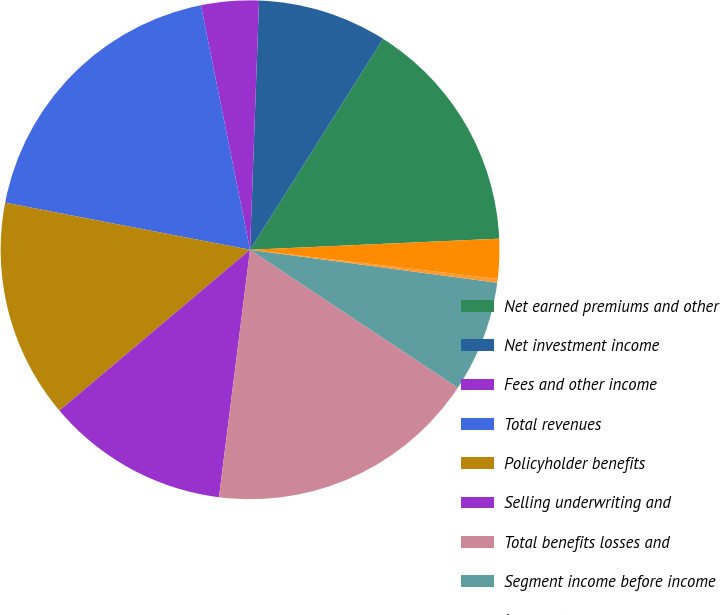<chart> <loc_0><loc_0><loc_500><loc_500><pie_chart><fcel>Net earned premiums and other<fcel>Net investment income<fcel>Fees and other income<fcel>Total revenues<fcel>Policyholder benefits<fcel>Selling underwriting and<fcel>Total benefits losses and<fcel>Segment income before income<fcel>Income taxes<fcel>Segment income after tax<nl><fcel>15.34%<fcel>8.38%<fcel>3.73%<fcel>18.82%<fcel>14.18%<fcel>11.86%<fcel>17.66%<fcel>7.22%<fcel>0.25%<fcel>2.57%<nl></chart> 